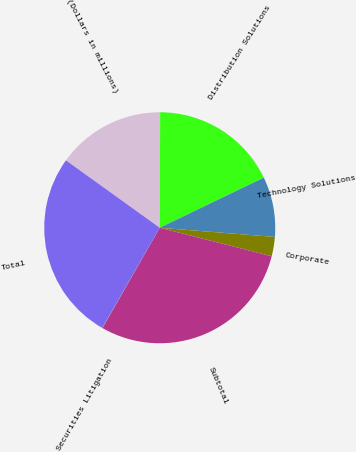Convert chart. <chart><loc_0><loc_0><loc_500><loc_500><pie_chart><fcel>(Dollars in millions)<fcel>Distribution Solutions<fcel>Technology Solutions<fcel>Corporate<fcel>Subtotal<fcel>Securities Litigation<fcel>Total<nl><fcel>15.14%<fcel>17.8%<fcel>8.41%<fcel>2.7%<fcel>29.29%<fcel>0.04%<fcel>26.62%<nl></chart> 